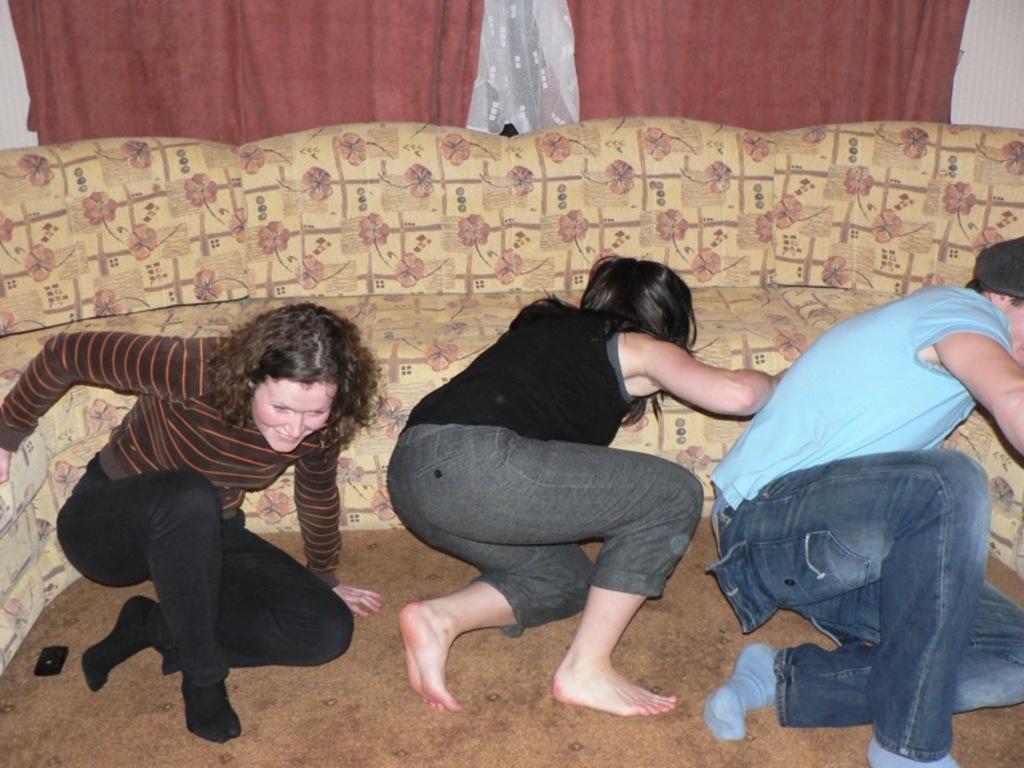Could you give a brief overview of what you see in this image? In this image we can see three people on the floor, also we can see a cell phone on it, behind them there is a couch, and curtains. 